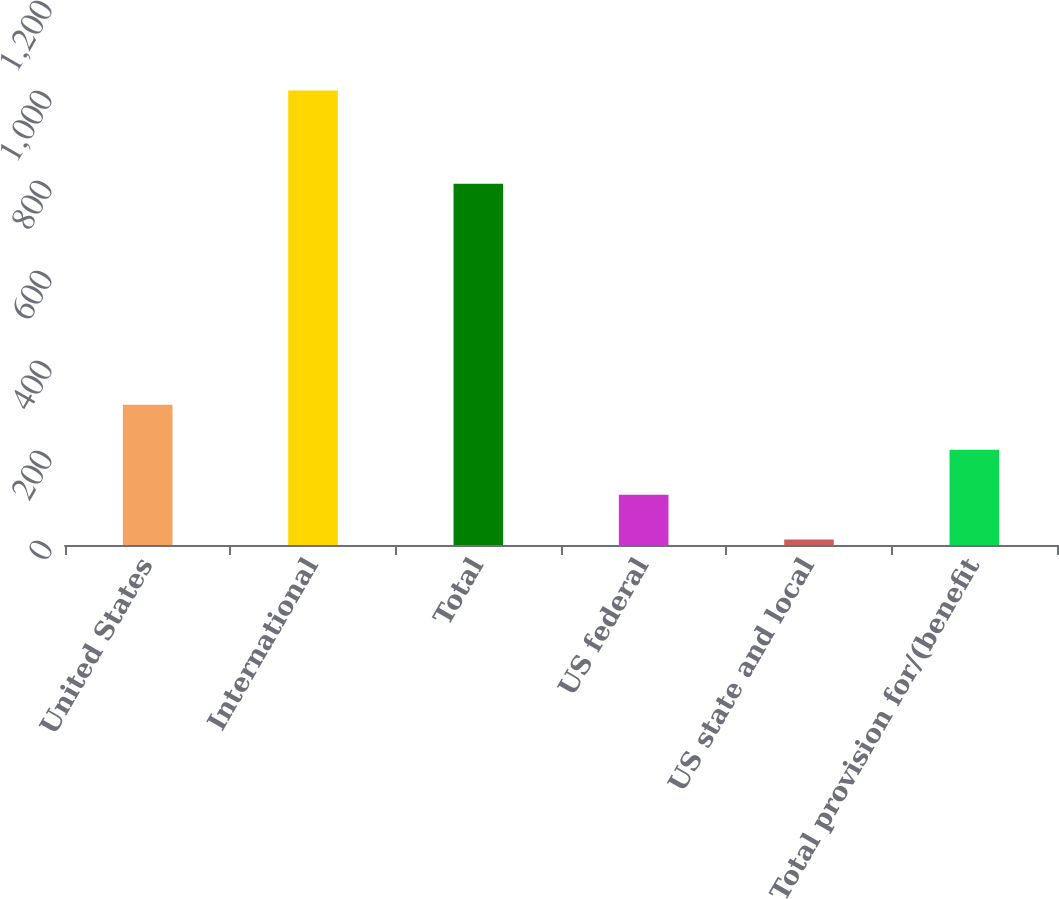Convert chart to OTSL. <chart><loc_0><loc_0><loc_500><loc_500><bar_chart><fcel>United States<fcel>International<fcel>Total<fcel>US federal<fcel>US state and local<fcel>Total provision for/(benefit<nl><fcel>311.4<fcel>1010<fcel>803<fcel>111.8<fcel>12<fcel>211.6<nl></chart> 